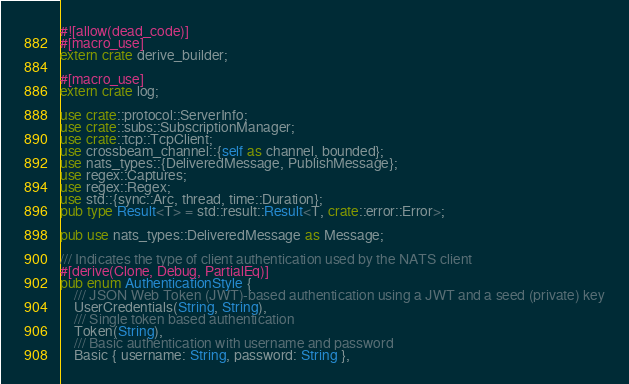<code> <loc_0><loc_0><loc_500><loc_500><_Rust_>#![allow(dead_code)]
#[macro_use]
extern crate derive_builder;

#[macro_use]
extern crate log;

use crate::protocol::ServerInfo;
use crate::subs::SubscriptionManager;
use crate::tcp::TcpClient;
use crossbeam_channel::{self as channel, bounded};
use nats_types::{DeliveredMessage, PublishMessage};
use regex::Captures;
use regex::Regex;
use std::{sync::Arc, thread, time::Duration};
pub type Result<T> = std::result::Result<T, crate::error::Error>;

pub use nats_types::DeliveredMessage as Message;

/// Indicates the type of client authentication used by the NATS client
#[derive(Clone, Debug, PartialEq)]
pub enum AuthenticationStyle {
    /// JSON Web Token (JWT)-based authentication using a JWT and a seed (private) key
    UserCredentials(String, String),
    /// Single token based authentication
    Token(String),
    /// Basic authentication with username and password
    Basic { username: String, password: String },</code> 